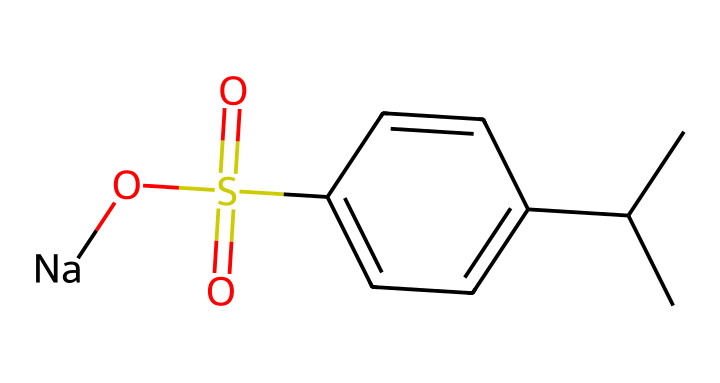What is the main functional group in this chemical? The structure contains a sulfonic acid group represented by the S(=O)(=O)O part, which is characteristic of surfactants like alkylbenzene sulfonates.
Answer: sulfonic acid How many carbon atoms are there in this molecule? The molecule can be analyzed by counting the 'C' atoms in the SMILES representation. There are a total of 10 carbon atoms in the entire structure.
Answer: 10 What is the ionic form of this detergent? The '[Na]' part of the SMILES indicates that this compound exists as a sodium salt, common in detergents to enhance solubility in water.
Answer: sodium salt What type of bond connects the carbon atoms to the sulfur atom? The carbon atoms in the aliphatic chain and the benzene ring are connected to the sulfur atom by single covalent bonds, typical for organic compounds with sulfur.
Answer: single covalent bonds Why is this compound effective as a detergent? The molecule's structure has both hydrophobic (the carbon chain) and hydrophilic (the sulfonic acid) components, which allows it to interact with both water and oils, making it effective for cleaning.
Answer: amphipathic What is the role of the benzene ring in this detergent? The benzene ring increases the hydrophobic character of the molecule, allowing it to interact with oils and greases, improving its cleaning ability.
Answer: increases hydrophobic character 